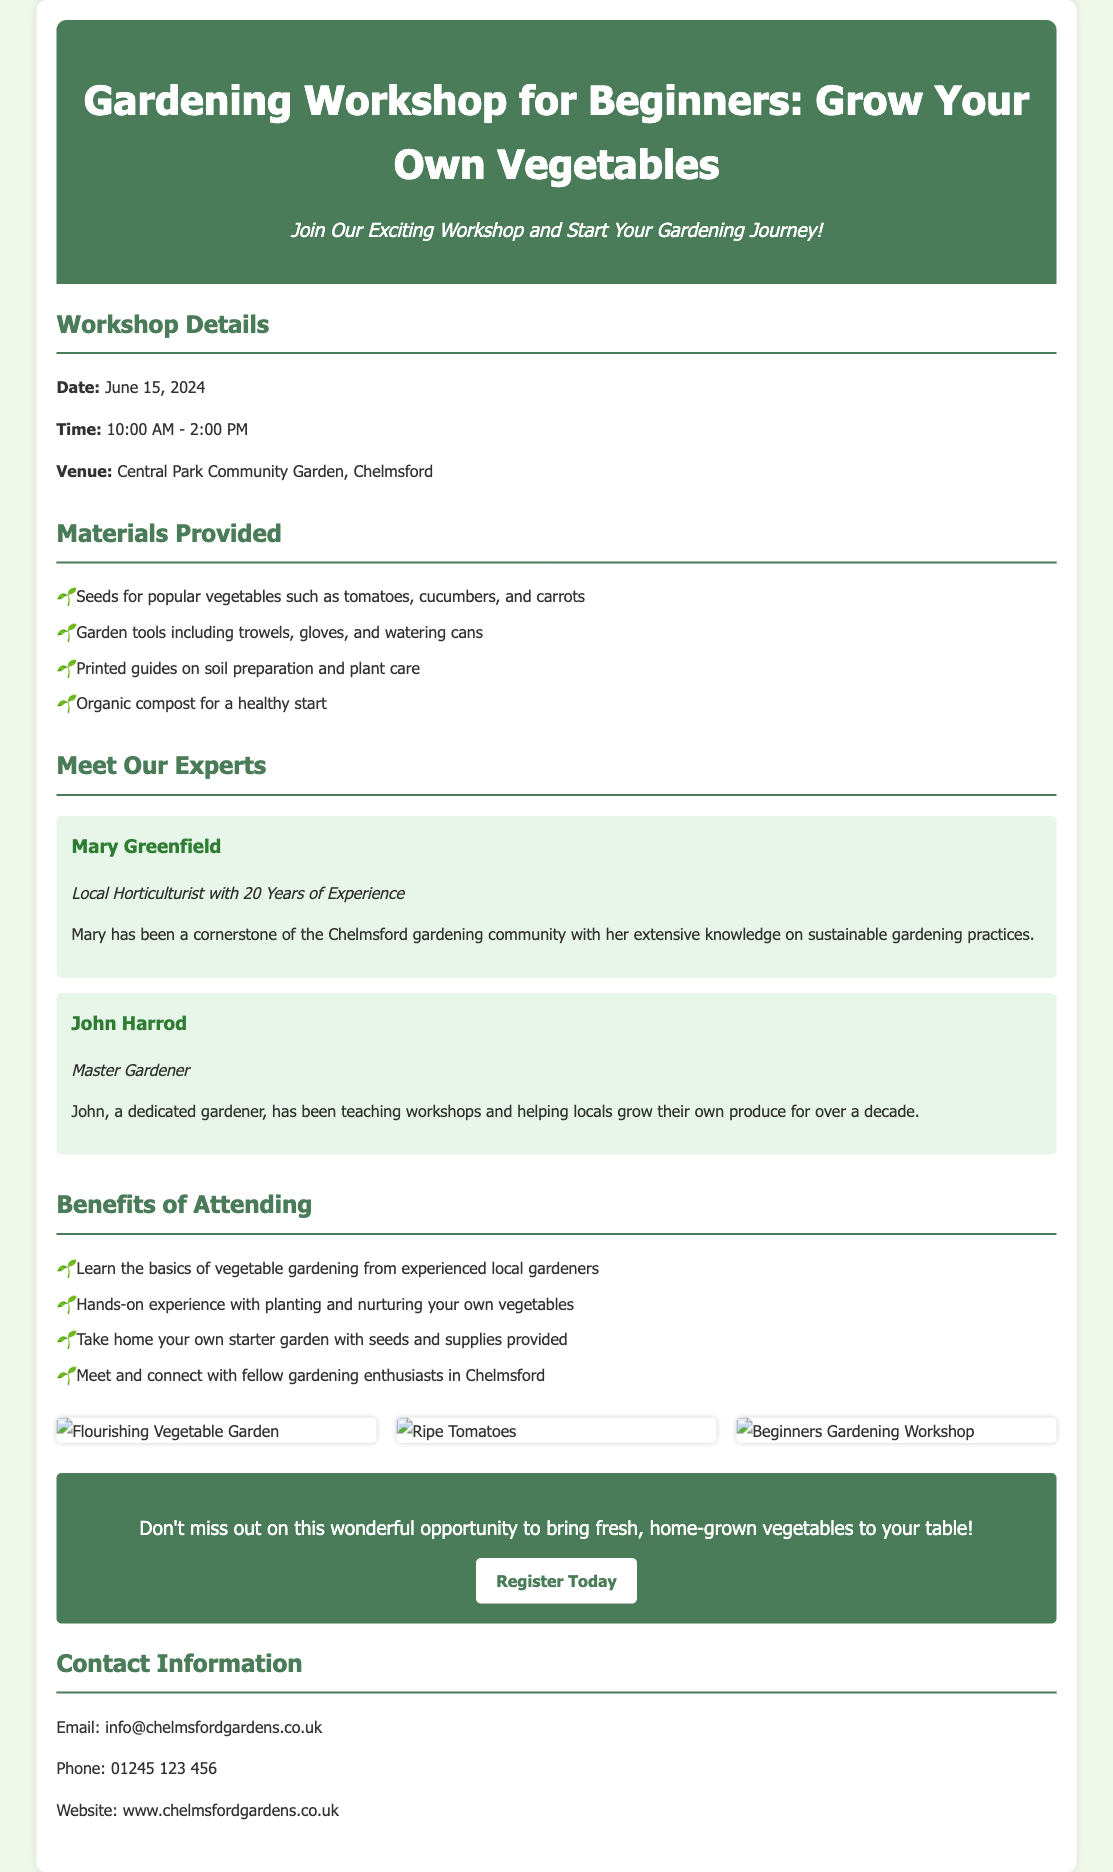What is the date of the workshop? The date of the workshop is clearly stated in the document as June 15, 2024.
Answer: June 15, 2024 What is the time of the workshop? The document specifies the workshop time as 10:00 AM - 2:00 PM.
Answer: 10:00 AM - 2:00 PM Where is the workshop venue located? The venue for the workshop is mentioned as Central Park Community Garden, Chelmsford.
Answer: Central Park Community Garden, Chelmsford Who is one of the facilitators? The document lists facilitators, and one is Mary Greenfield, a local horticulturist.
Answer: Mary Greenfield What materials will participants receive? The workshop provides various materials, including seeds for popular vegetables, as outlined in the document.
Answer: Seeds for popular vegetables What is one benefit of attending the workshop? A listed benefit is that attendees can learn the basics of vegetable gardening from experienced local gardeners.
Answer: Learn the basics of vegetable gardening How many images are displayed in the advertisement? The document shows that there are three images related to the workshop.
Answer: Three images What can participants take home after the workshop? The advertisement states that participants can take home their own starter garden with seeds and supplies provided.
Answer: Starter garden with seeds and supplies What does the call-to-action encourage? The call-to-action in the document encourages readers to register for the workshop.
Answer: Register for the workshop 